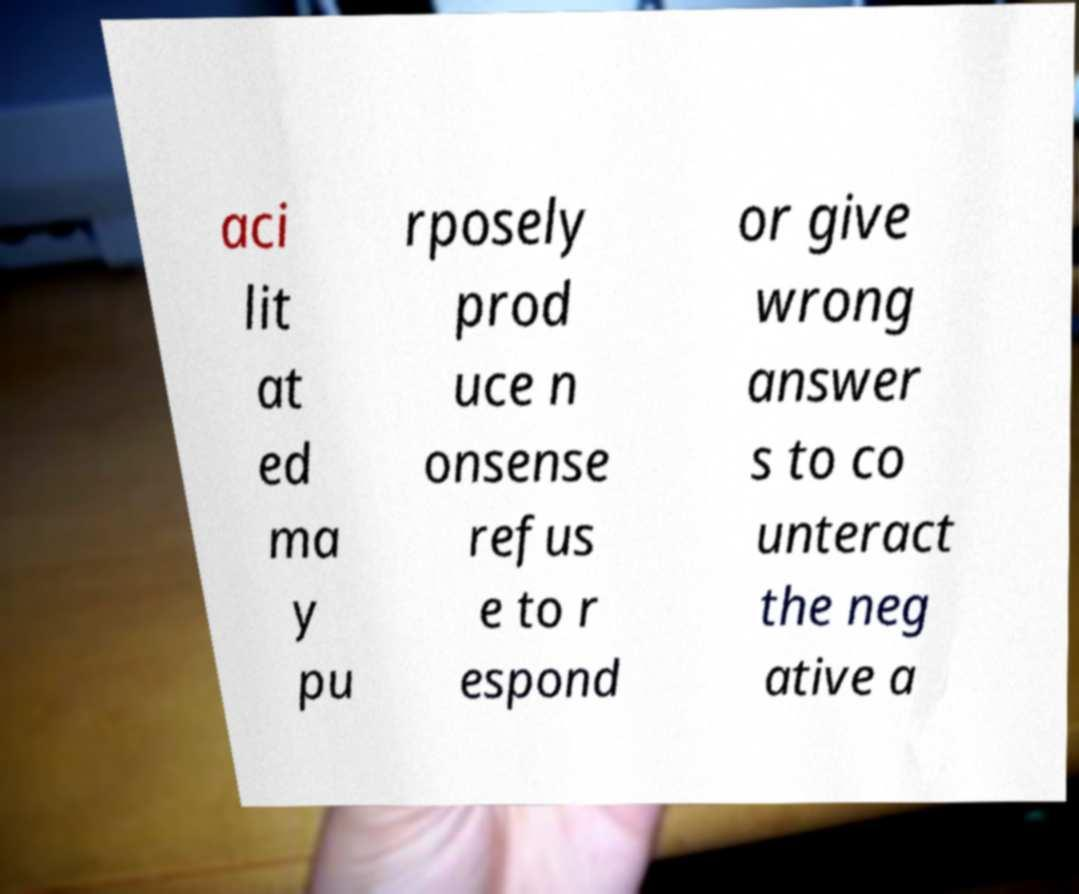There's text embedded in this image that I need extracted. Can you transcribe it verbatim? aci lit at ed ma y pu rposely prod uce n onsense refus e to r espond or give wrong answer s to co unteract the neg ative a 